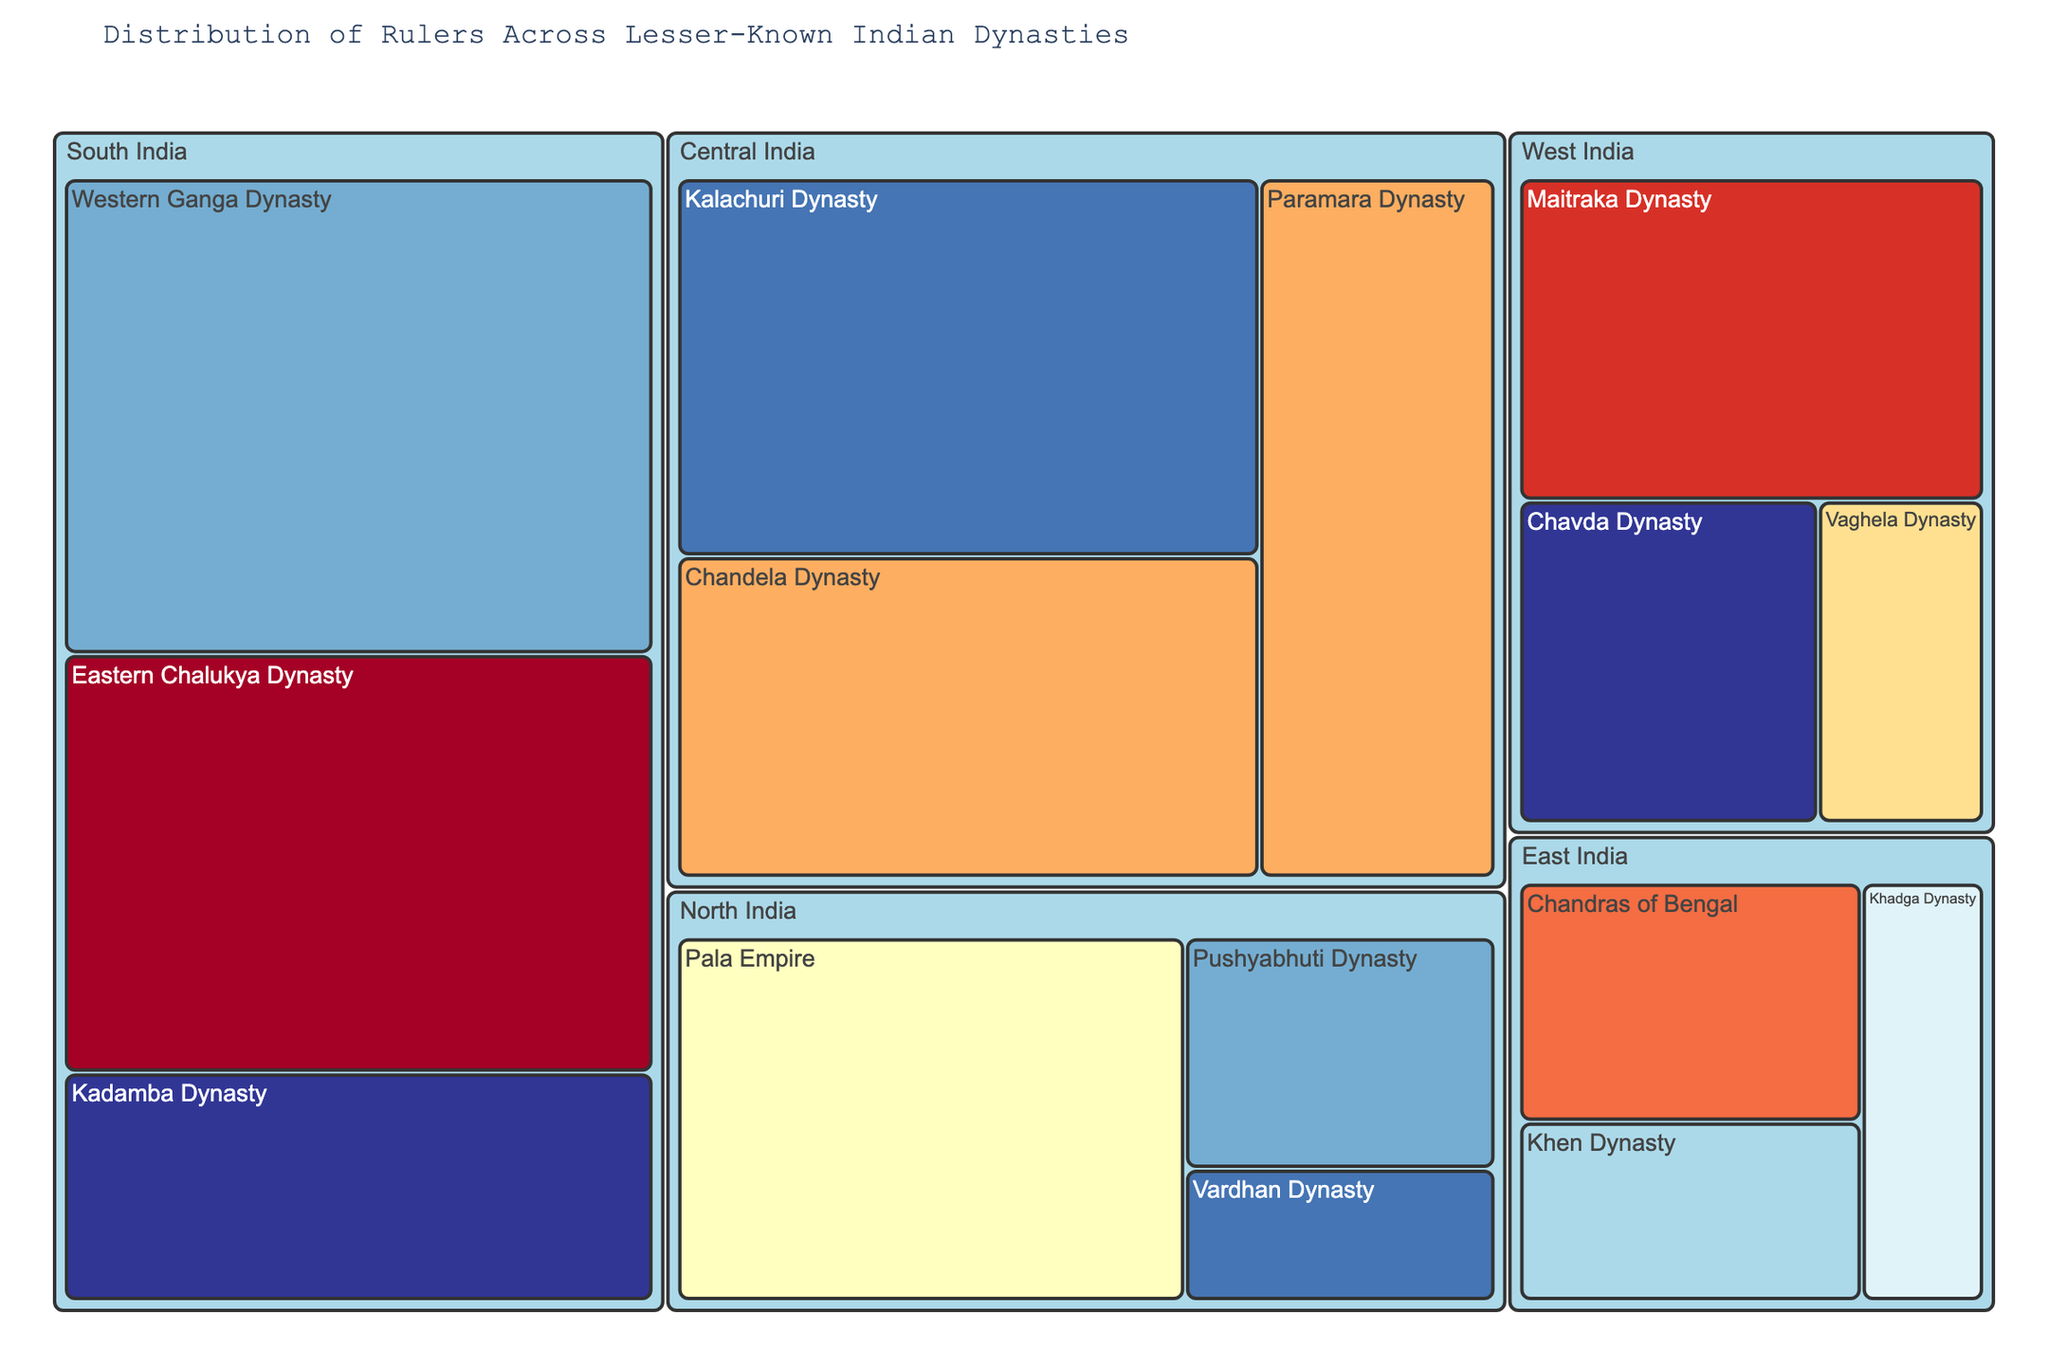What is the title of the treemap? The title is usually displayed prominently at the top of the chart. It serves as an immediate introduction to the content being visualized.
Answer: Distribution of Rulers Across Lesser-Known Indian Dynasties Which dynasty in North India had the highest number of rulers? To determine this, look for the largest segment by size under the North India region. Each segment's size is proportional to the number of rulers. The largest segment under "North India" corresponds to the Pala Empire, which indicates it had the highest number of rulers.
Answer: Pala Empire How many dynasties are represented in South India? To find this, count the distinct dynasties listed under the South India region. Each segment within this region corresponds to a different dynasty.
Answer: 3 Which region had the most rulers overall? To determine this, sum the number of rulers for each dynasty within each region and compare the totals across regions. The region with the highest total is the one with the most rulers.
Answer: South India What is the time period for the Kadamba Dynasty? The time period for each dynasty is included in the hover data. When looking at the segment for the Kadamba Dynasty, the time period appears in the hover data.
Answer: 4th-6th century CE How does the number of rulers in the Kalachuri Dynasty compare to that in the Paramara Dynasty? For comparison, identify the number of rulers in both the Kalachuri and Paramara dynasties as shown on their respective segments. Kalachuri has 20 rulers, and Paramara has 15. Therefore, Kalachuri has more rulers.
Answer: Kalachuri Dynasty > Paramara Dynasty Which dynasty under West India had rulers during the 13th-14th century CE? Look for the dynasty in the West India region whose segment is color-coded to correspond with the 13th-14th century CE time period. This will be indicated in the hover data as well.
Answer: Vaghela Dynasty What is the combined number of rulers from the Chandras of Bengal and the Khen Dynasty? Add the number of rulers from both dynasties. Chandras of Bengal have 8 rulers and Khen Dynasty have 6 rulers. The combined total is 8 + 6.
Answer: 14 Which region features the Chandela Dynasty? Identify the region by examining the hierarchy structure of the segments. The Chandela Dynasty appears under the region categorization titled Central India.
Answer: Central India 